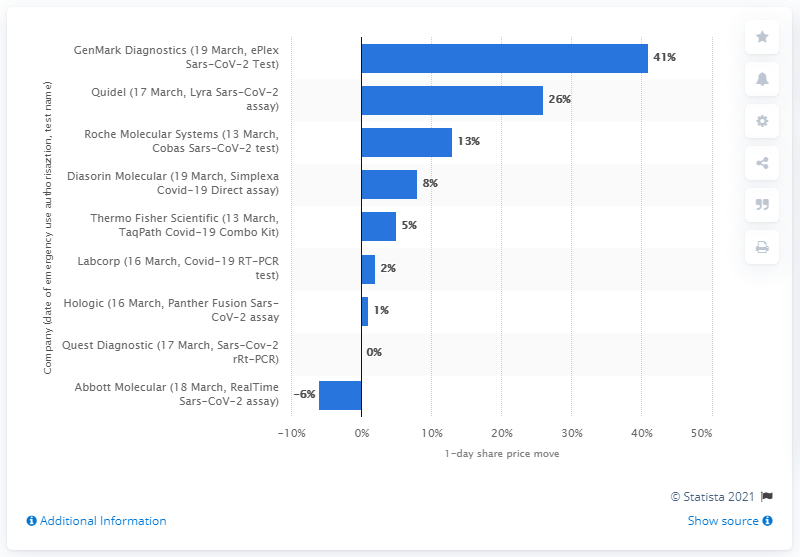Identify some key points in this picture. The sum of the two highest values is 67. GenMark Diagnostics' share price increased by 41% following the approval of its EUA. The Abbott Molecular share has a negative share price as of March 18, 2020, in response to the release of its RealTime Sars-CoV-2 assay. 